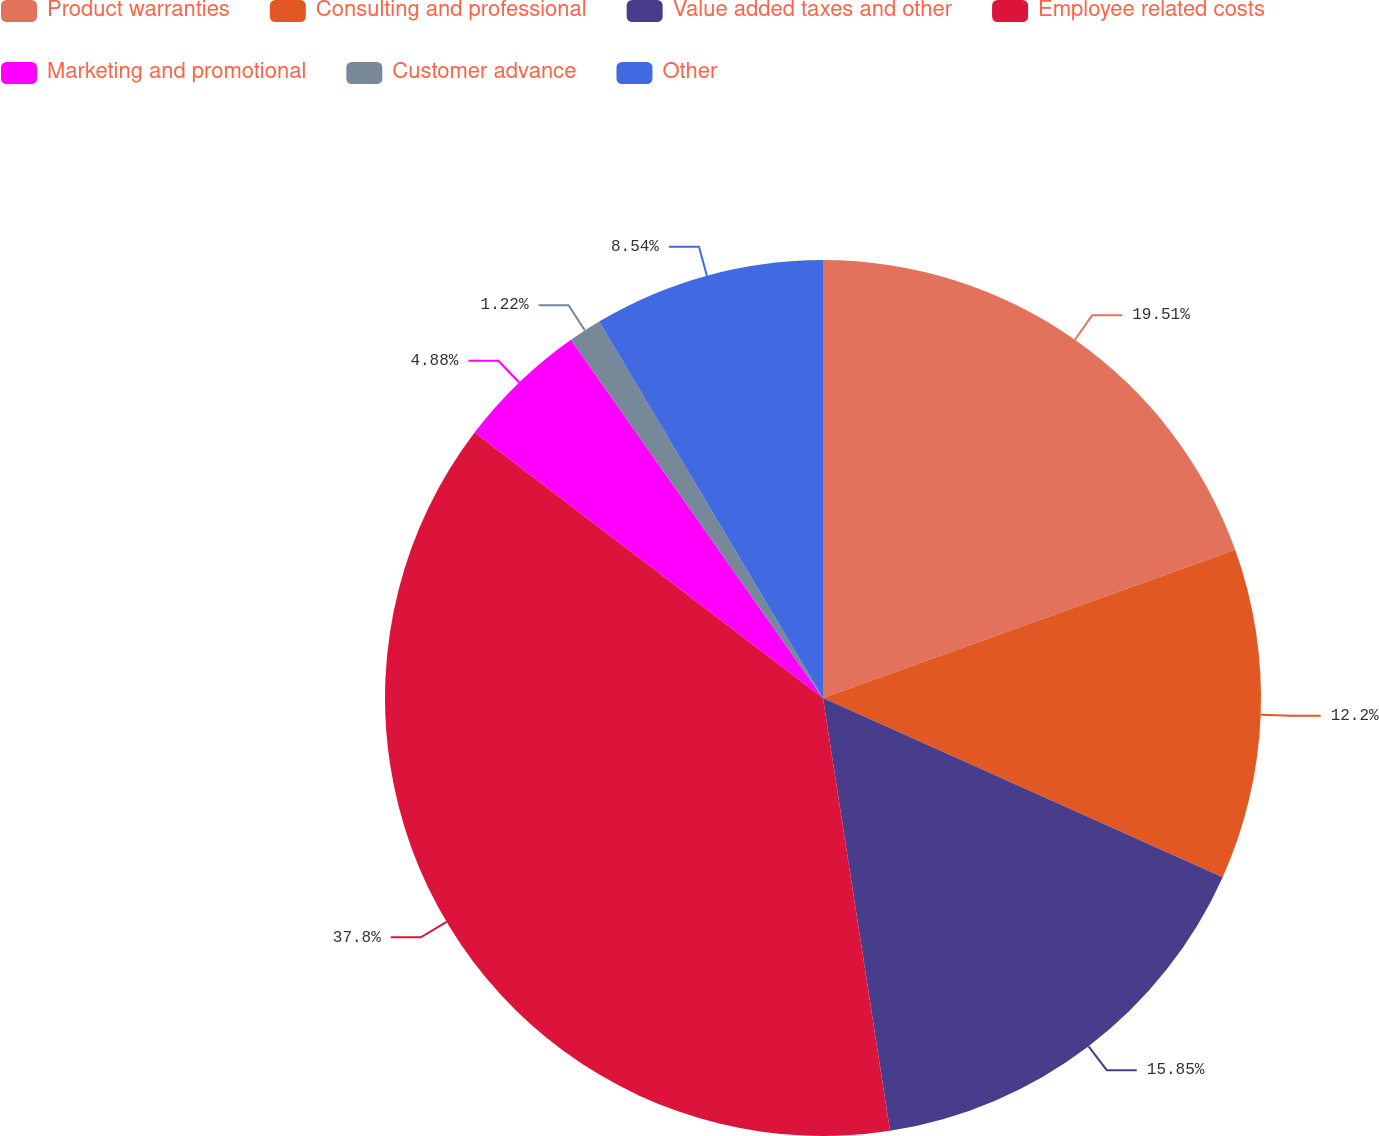<chart> <loc_0><loc_0><loc_500><loc_500><pie_chart><fcel>Product warranties<fcel>Consulting and professional<fcel>Value added taxes and other<fcel>Employee related costs<fcel>Marketing and promotional<fcel>Customer advance<fcel>Other<nl><fcel>19.51%<fcel>12.2%<fcel>15.85%<fcel>37.81%<fcel>4.88%<fcel>1.22%<fcel>8.54%<nl></chart> 